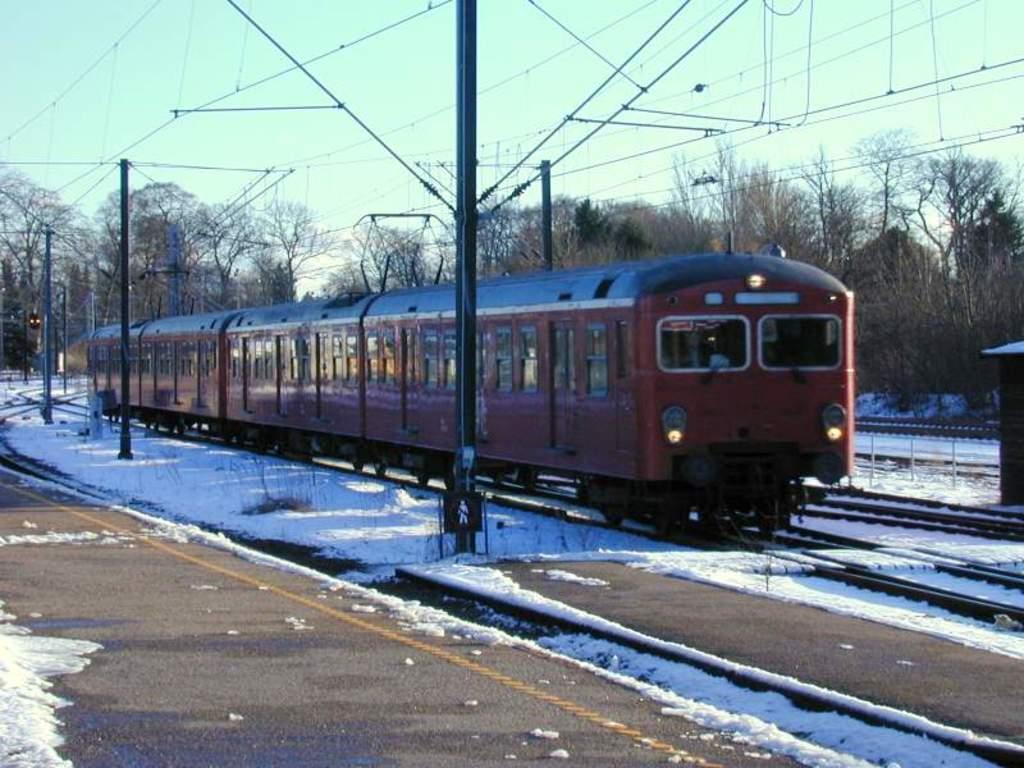Can you describe this image briefly? In this image we can see a train on the track and there are poles. In the background there are trees and sky. At the top there are wires and we can see snow. 